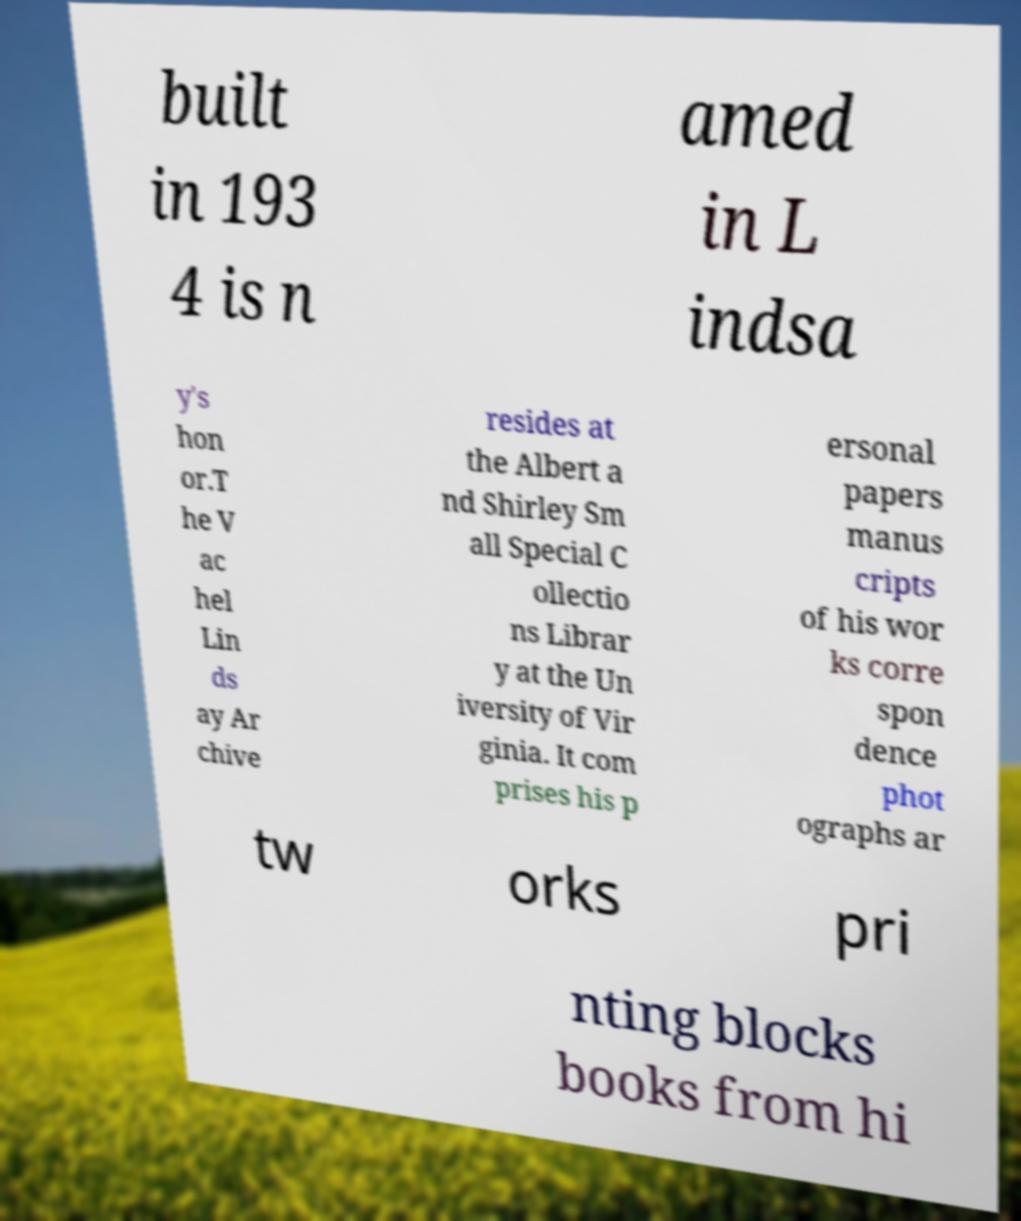What messages or text are displayed in this image? I need them in a readable, typed format. built in 193 4 is n amed in L indsa y's hon or.T he V ac hel Lin ds ay Ar chive resides at the Albert a nd Shirley Sm all Special C ollectio ns Librar y at the Un iversity of Vir ginia. It com prises his p ersonal papers manus cripts of his wor ks corre spon dence phot ographs ar tw orks pri nting blocks books from hi 